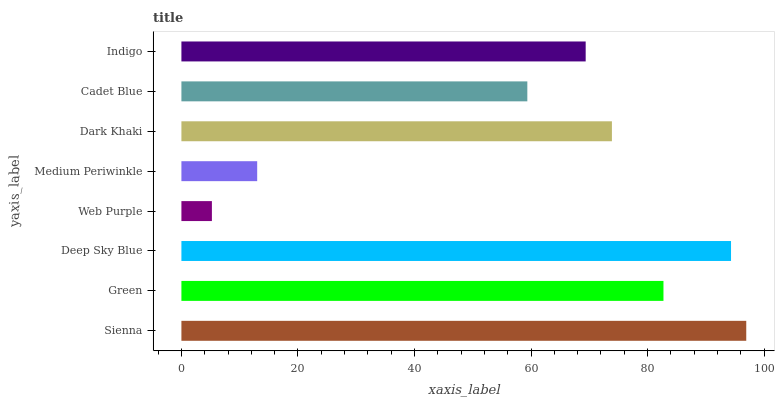Is Web Purple the minimum?
Answer yes or no. Yes. Is Sienna the maximum?
Answer yes or no. Yes. Is Green the minimum?
Answer yes or no. No. Is Green the maximum?
Answer yes or no. No. Is Sienna greater than Green?
Answer yes or no. Yes. Is Green less than Sienna?
Answer yes or no. Yes. Is Green greater than Sienna?
Answer yes or no. No. Is Sienna less than Green?
Answer yes or no. No. Is Dark Khaki the high median?
Answer yes or no. Yes. Is Indigo the low median?
Answer yes or no. Yes. Is Medium Periwinkle the high median?
Answer yes or no. No. Is Deep Sky Blue the low median?
Answer yes or no. No. 